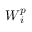Convert formula to latex. <formula><loc_0><loc_0><loc_500><loc_500>W _ { i } ^ { p }</formula> 